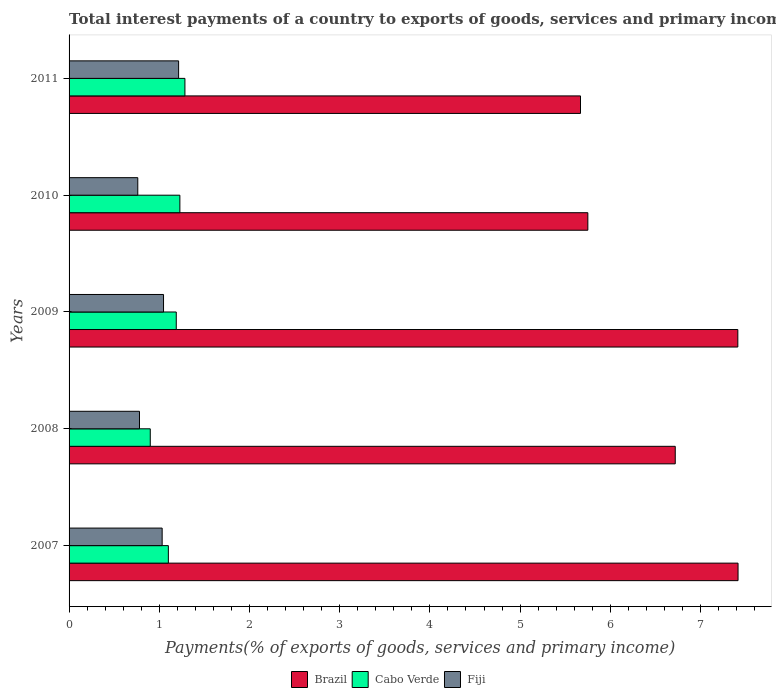How many groups of bars are there?
Your answer should be very brief. 5. Are the number of bars on each tick of the Y-axis equal?
Ensure brevity in your answer.  Yes. How many bars are there on the 3rd tick from the bottom?
Offer a very short reply. 3. What is the total interest payments in Fiji in 2008?
Offer a terse response. 0.78. Across all years, what is the maximum total interest payments in Fiji?
Provide a short and direct response. 1.21. Across all years, what is the minimum total interest payments in Cabo Verde?
Offer a terse response. 0.9. In which year was the total interest payments in Brazil maximum?
Keep it short and to the point. 2007. In which year was the total interest payments in Cabo Verde minimum?
Your answer should be compact. 2008. What is the total total interest payments in Brazil in the graph?
Ensure brevity in your answer.  32.97. What is the difference between the total interest payments in Cabo Verde in 2008 and that in 2011?
Your answer should be very brief. -0.38. What is the difference between the total interest payments in Fiji in 2010 and the total interest payments in Brazil in 2009?
Provide a succinct answer. -6.65. What is the average total interest payments in Fiji per year?
Your answer should be very brief. 0.97. In the year 2010, what is the difference between the total interest payments in Cabo Verde and total interest payments in Brazil?
Make the answer very short. -4.52. In how many years, is the total interest payments in Cabo Verde greater than 4 %?
Offer a terse response. 0. What is the ratio of the total interest payments in Cabo Verde in 2007 to that in 2009?
Offer a very short reply. 0.93. Is the total interest payments in Fiji in 2009 less than that in 2010?
Ensure brevity in your answer.  No. What is the difference between the highest and the second highest total interest payments in Cabo Verde?
Provide a short and direct response. 0.06. What is the difference between the highest and the lowest total interest payments in Brazil?
Make the answer very short. 1.75. In how many years, is the total interest payments in Brazil greater than the average total interest payments in Brazil taken over all years?
Offer a terse response. 3. What does the 3rd bar from the bottom in 2007 represents?
Provide a succinct answer. Fiji. Is it the case that in every year, the sum of the total interest payments in Fiji and total interest payments in Brazil is greater than the total interest payments in Cabo Verde?
Give a very brief answer. Yes. How many years are there in the graph?
Provide a short and direct response. 5. What is the difference between two consecutive major ticks on the X-axis?
Your answer should be very brief. 1. Where does the legend appear in the graph?
Your answer should be compact. Bottom center. How many legend labels are there?
Your answer should be compact. 3. How are the legend labels stacked?
Offer a terse response. Horizontal. What is the title of the graph?
Give a very brief answer. Total interest payments of a country to exports of goods, services and primary income. Does "New Caledonia" appear as one of the legend labels in the graph?
Your response must be concise. No. What is the label or title of the X-axis?
Offer a very short reply. Payments(% of exports of goods, services and primary income). What is the Payments(% of exports of goods, services and primary income) in Brazil in 2007?
Offer a terse response. 7.42. What is the Payments(% of exports of goods, services and primary income) of Cabo Verde in 2007?
Provide a succinct answer. 1.1. What is the Payments(% of exports of goods, services and primary income) in Fiji in 2007?
Make the answer very short. 1.03. What is the Payments(% of exports of goods, services and primary income) in Brazil in 2008?
Ensure brevity in your answer.  6.72. What is the Payments(% of exports of goods, services and primary income) in Cabo Verde in 2008?
Give a very brief answer. 0.9. What is the Payments(% of exports of goods, services and primary income) of Fiji in 2008?
Provide a short and direct response. 0.78. What is the Payments(% of exports of goods, services and primary income) in Brazil in 2009?
Offer a very short reply. 7.41. What is the Payments(% of exports of goods, services and primary income) of Cabo Verde in 2009?
Make the answer very short. 1.19. What is the Payments(% of exports of goods, services and primary income) in Fiji in 2009?
Give a very brief answer. 1.05. What is the Payments(% of exports of goods, services and primary income) in Brazil in 2010?
Make the answer very short. 5.75. What is the Payments(% of exports of goods, services and primary income) of Cabo Verde in 2010?
Provide a short and direct response. 1.23. What is the Payments(% of exports of goods, services and primary income) in Fiji in 2010?
Make the answer very short. 0.76. What is the Payments(% of exports of goods, services and primary income) in Brazil in 2011?
Your answer should be compact. 5.67. What is the Payments(% of exports of goods, services and primary income) of Cabo Verde in 2011?
Offer a very short reply. 1.28. What is the Payments(% of exports of goods, services and primary income) of Fiji in 2011?
Your response must be concise. 1.21. Across all years, what is the maximum Payments(% of exports of goods, services and primary income) of Brazil?
Ensure brevity in your answer.  7.42. Across all years, what is the maximum Payments(% of exports of goods, services and primary income) of Cabo Verde?
Offer a terse response. 1.28. Across all years, what is the maximum Payments(% of exports of goods, services and primary income) of Fiji?
Give a very brief answer. 1.21. Across all years, what is the minimum Payments(% of exports of goods, services and primary income) in Brazil?
Your response must be concise. 5.67. Across all years, what is the minimum Payments(% of exports of goods, services and primary income) of Cabo Verde?
Provide a short and direct response. 0.9. Across all years, what is the minimum Payments(% of exports of goods, services and primary income) in Fiji?
Offer a terse response. 0.76. What is the total Payments(% of exports of goods, services and primary income) of Brazil in the graph?
Give a very brief answer. 32.97. What is the total Payments(% of exports of goods, services and primary income) of Cabo Verde in the graph?
Ensure brevity in your answer.  5.7. What is the total Payments(% of exports of goods, services and primary income) of Fiji in the graph?
Offer a terse response. 4.84. What is the difference between the Payments(% of exports of goods, services and primary income) in Brazil in 2007 and that in 2008?
Make the answer very short. 0.7. What is the difference between the Payments(% of exports of goods, services and primary income) in Cabo Verde in 2007 and that in 2008?
Your answer should be compact. 0.2. What is the difference between the Payments(% of exports of goods, services and primary income) of Fiji in 2007 and that in 2008?
Ensure brevity in your answer.  0.25. What is the difference between the Payments(% of exports of goods, services and primary income) of Brazil in 2007 and that in 2009?
Provide a succinct answer. 0. What is the difference between the Payments(% of exports of goods, services and primary income) in Cabo Verde in 2007 and that in 2009?
Provide a short and direct response. -0.09. What is the difference between the Payments(% of exports of goods, services and primary income) in Fiji in 2007 and that in 2009?
Offer a very short reply. -0.02. What is the difference between the Payments(% of exports of goods, services and primary income) in Brazil in 2007 and that in 2010?
Offer a very short reply. 1.67. What is the difference between the Payments(% of exports of goods, services and primary income) of Cabo Verde in 2007 and that in 2010?
Your answer should be compact. -0.13. What is the difference between the Payments(% of exports of goods, services and primary income) in Fiji in 2007 and that in 2010?
Provide a succinct answer. 0.27. What is the difference between the Payments(% of exports of goods, services and primary income) in Brazil in 2007 and that in 2011?
Make the answer very short. 1.75. What is the difference between the Payments(% of exports of goods, services and primary income) in Cabo Verde in 2007 and that in 2011?
Provide a short and direct response. -0.18. What is the difference between the Payments(% of exports of goods, services and primary income) of Fiji in 2007 and that in 2011?
Make the answer very short. -0.18. What is the difference between the Payments(% of exports of goods, services and primary income) in Brazil in 2008 and that in 2009?
Ensure brevity in your answer.  -0.69. What is the difference between the Payments(% of exports of goods, services and primary income) in Cabo Verde in 2008 and that in 2009?
Ensure brevity in your answer.  -0.29. What is the difference between the Payments(% of exports of goods, services and primary income) in Fiji in 2008 and that in 2009?
Your answer should be compact. -0.27. What is the difference between the Payments(% of exports of goods, services and primary income) in Brazil in 2008 and that in 2010?
Offer a very short reply. 0.97. What is the difference between the Payments(% of exports of goods, services and primary income) in Cabo Verde in 2008 and that in 2010?
Keep it short and to the point. -0.33. What is the difference between the Payments(% of exports of goods, services and primary income) in Fiji in 2008 and that in 2010?
Provide a succinct answer. 0.02. What is the difference between the Payments(% of exports of goods, services and primary income) of Brazil in 2008 and that in 2011?
Your response must be concise. 1.05. What is the difference between the Payments(% of exports of goods, services and primary income) of Cabo Verde in 2008 and that in 2011?
Your response must be concise. -0.38. What is the difference between the Payments(% of exports of goods, services and primary income) in Fiji in 2008 and that in 2011?
Keep it short and to the point. -0.43. What is the difference between the Payments(% of exports of goods, services and primary income) of Brazil in 2009 and that in 2010?
Your answer should be compact. 1.66. What is the difference between the Payments(% of exports of goods, services and primary income) in Cabo Verde in 2009 and that in 2010?
Make the answer very short. -0.04. What is the difference between the Payments(% of exports of goods, services and primary income) of Fiji in 2009 and that in 2010?
Offer a very short reply. 0.29. What is the difference between the Payments(% of exports of goods, services and primary income) of Brazil in 2009 and that in 2011?
Make the answer very short. 1.74. What is the difference between the Payments(% of exports of goods, services and primary income) in Cabo Verde in 2009 and that in 2011?
Keep it short and to the point. -0.1. What is the difference between the Payments(% of exports of goods, services and primary income) in Fiji in 2009 and that in 2011?
Ensure brevity in your answer.  -0.17. What is the difference between the Payments(% of exports of goods, services and primary income) of Brazil in 2010 and that in 2011?
Provide a short and direct response. 0.08. What is the difference between the Payments(% of exports of goods, services and primary income) of Cabo Verde in 2010 and that in 2011?
Provide a succinct answer. -0.06. What is the difference between the Payments(% of exports of goods, services and primary income) of Fiji in 2010 and that in 2011?
Give a very brief answer. -0.45. What is the difference between the Payments(% of exports of goods, services and primary income) of Brazil in 2007 and the Payments(% of exports of goods, services and primary income) of Cabo Verde in 2008?
Provide a short and direct response. 6.52. What is the difference between the Payments(% of exports of goods, services and primary income) of Brazil in 2007 and the Payments(% of exports of goods, services and primary income) of Fiji in 2008?
Give a very brief answer. 6.64. What is the difference between the Payments(% of exports of goods, services and primary income) of Cabo Verde in 2007 and the Payments(% of exports of goods, services and primary income) of Fiji in 2008?
Offer a very short reply. 0.32. What is the difference between the Payments(% of exports of goods, services and primary income) in Brazil in 2007 and the Payments(% of exports of goods, services and primary income) in Cabo Verde in 2009?
Make the answer very short. 6.23. What is the difference between the Payments(% of exports of goods, services and primary income) in Brazil in 2007 and the Payments(% of exports of goods, services and primary income) in Fiji in 2009?
Your response must be concise. 6.37. What is the difference between the Payments(% of exports of goods, services and primary income) of Cabo Verde in 2007 and the Payments(% of exports of goods, services and primary income) of Fiji in 2009?
Make the answer very short. 0.05. What is the difference between the Payments(% of exports of goods, services and primary income) in Brazil in 2007 and the Payments(% of exports of goods, services and primary income) in Cabo Verde in 2010?
Keep it short and to the point. 6.19. What is the difference between the Payments(% of exports of goods, services and primary income) of Brazil in 2007 and the Payments(% of exports of goods, services and primary income) of Fiji in 2010?
Offer a terse response. 6.65. What is the difference between the Payments(% of exports of goods, services and primary income) of Cabo Verde in 2007 and the Payments(% of exports of goods, services and primary income) of Fiji in 2010?
Ensure brevity in your answer.  0.34. What is the difference between the Payments(% of exports of goods, services and primary income) in Brazil in 2007 and the Payments(% of exports of goods, services and primary income) in Cabo Verde in 2011?
Your response must be concise. 6.13. What is the difference between the Payments(% of exports of goods, services and primary income) in Brazil in 2007 and the Payments(% of exports of goods, services and primary income) in Fiji in 2011?
Ensure brevity in your answer.  6.2. What is the difference between the Payments(% of exports of goods, services and primary income) in Cabo Verde in 2007 and the Payments(% of exports of goods, services and primary income) in Fiji in 2011?
Ensure brevity in your answer.  -0.11. What is the difference between the Payments(% of exports of goods, services and primary income) of Brazil in 2008 and the Payments(% of exports of goods, services and primary income) of Cabo Verde in 2009?
Keep it short and to the point. 5.53. What is the difference between the Payments(% of exports of goods, services and primary income) in Brazil in 2008 and the Payments(% of exports of goods, services and primary income) in Fiji in 2009?
Make the answer very short. 5.67. What is the difference between the Payments(% of exports of goods, services and primary income) of Cabo Verde in 2008 and the Payments(% of exports of goods, services and primary income) of Fiji in 2009?
Your response must be concise. -0.15. What is the difference between the Payments(% of exports of goods, services and primary income) of Brazil in 2008 and the Payments(% of exports of goods, services and primary income) of Cabo Verde in 2010?
Make the answer very short. 5.49. What is the difference between the Payments(% of exports of goods, services and primary income) of Brazil in 2008 and the Payments(% of exports of goods, services and primary income) of Fiji in 2010?
Give a very brief answer. 5.96. What is the difference between the Payments(% of exports of goods, services and primary income) in Cabo Verde in 2008 and the Payments(% of exports of goods, services and primary income) in Fiji in 2010?
Offer a terse response. 0.14. What is the difference between the Payments(% of exports of goods, services and primary income) of Brazil in 2008 and the Payments(% of exports of goods, services and primary income) of Cabo Verde in 2011?
Give a very brief answer. 5.44. What is the difference between the Payments(% of exports of goods, services and primary income) of Brazil in 2008 and the Payments(% of exports of goods, services and primary income) of Fiji in 2011?
Provide a short and direct response. 5.51. What is the difference between the Payments(% of exports of goods, services and primary income) of Cabo Verde in 2008 and the Payments(% of exports of goods, services and primary income) of Fiji in 2011?
Keep it short and to the point. -0.31. What is the difference between the Payments(% of exports of goods, services and primary income) of Brazil in 2009 and the Payments(% of exports of goods, services and primary income) of Cabo Verde in 2010?
Offer a very short reply. 6.19. What is the difference between the Payments(% of exports of goods, services and primary income) of Brazil in 2009 and the Payments(% of exports of goods, services and primary income) of Fiji in 2010?
Make the answer very short. 6.65. What is the difference between the Payments(% of exports of goods, services and primary income) of Cabo Verde in 2009 and the Payments(% of exports of goods, services and primary income) of Fiji in 2010?
Ensure brevity in your answer.  0.43. What is the difference between the Payments(% of exports of goods, services and primary income) of Brazil in 2009 and the Payments(% of exports of goods, services and primary income) of Cabo Verde in 2011?
Make the answer very short. 6.13. What is the difference between the Payments(% of exports of goods, services and primary income) of Brazil in 2009 and the Payments(% of exports of goods, services and primary income) of Fiji in 2011?
Ensure brevity in your answer.  6.2. What is the difference between the Payments(% of exports of goods, services and primary income) of Cabo Verde in 2009 and the Payments(% of exports of goods, services and primary income) of Fiji in 2011?
Make the answer very short. -0.03. What is the difference between the Payments(% of exports of goods, services and primary income) in Brazil in 2010 and the Payments(% of exports of goods, services and primary income) in Cabo Verde in 2011?
Your answer should be very brief. 4.47. What is the difference between the Payments(% of exports of goods, services and primary income) of Brazil in 2010 and the Payments(% of exports of goods, services and primary income) of Fiji in 2011?
Provide a short and direct response. 4.54. What is the difference between the Payments(% of exports of goods, services and primary income) of Cabo Verde in 2010 and the Payments(% of exports of goods, services and primary income) of Fiji in 2011?
Your response must be concise. 0.01. What is the average Payments(% of exports of goods, services and primary income) in Brazil per year?
Your response must be concise. 6.59. What is the average Payments(% of exports of goods, services and primary income) in Cabo Verde per year?
Your answer should be very brief. 1.14. What is the average Payments(% of exports of goods, services and primary income) in Fiji per year?
Your answer should be very brief. 0.97. In the year 2007, what is the difference between the Payments(% of exports of goods, services and primary income) of Brazil and Payments(% of exports of goods, services and primary income) of Cabo Verde?
Provide a short and direct response. 6.32. In the year 2007, what is the difference between the Payments(% of exports of goods, services and primary income) of Brazil and Payments(% of exports of goods, services and primary income) of Fiji?
Offer a very short reply. 6.38. In the year 2007, what is the difference between the Payments(% of exports of goods, services and primary income) of Cabo Verde and Payments(% of exports of goods, services and primary income) of Fiji?
Keep it short and to the point. 0.07. In the year 2008, what is the difference between the Payments(% of exports of goods, services and primary income) in Brazil and Payments(% of exports of goods, services and primary income) in Cabo Verde?
Your answer should be very brief. 5.82. In the year 2008, what is the difference between the Payments(% of exports of goods, services and primary income) in Brazil and Payments(% of exports of goods, services and primary income) in Fiji?
Ensure brevity in your answer.  5.94. In the year 2008, what is the difference between the Payments(% of exports of goods, services and primary income) of Cabo Verde and Payments(% of exports of goods, services and primary income) of Fiji?
Ensure brevity in your answer.  0.12. In the year 2009, what is the difference between the Payments(% of exports of goods, services and primary income) of Brazil and Payments(% of exports of goods, services and primary income) of Cabo Verde?
Keep it short and to the point. 6.23. In the year 2009, what is the difference between the Payments(% of exports of goods, services and primary income) of Brazil and Payments(% of exports of goods, services and primary income) of Fiji?
Provide a short and direct response. 6.37. In the year 2009, what is the difference between the Payments(% of exports of goods, services and primary income) in Cabo Verde and Payments(% of exports of goods, services and primary income) in Fiji?
Your answer should be very brief. 0.14. In the year 2010, what is the difference between the Payments(% of exports of goods, services and primary income) of Brazil and Payments(% of exports of goods, services and primary income) of Cabo Verde?
Your answer should be very brief. 4.52. In the year 2010, what is the difference between the Payments(% of exports of goods, services and primary income) of Brazil and Payments(% of exports of goods, services and primary income) of Fiji?
Your answer should be very brief. 4.99. In the year 2010, what is the difference between the Payments(% of exports of goods, services and primary income) in Cabo Verde and Payments(% of exports of goods, services and primary income) in Fiji?
Your answer should be compact. 0.47. In the year 2011, what is the difference between the Payments(% of exports of goods, services and primary income) in Brazil and Payments(% of exports of goods, services and primary income) in Cabo Verde?
Your answer should be compact. 4.39. In the year 2011, what is the difference between the Payments(% of exports of goods, services and primary income) of Brazil and Payments(% of exports of goods, services and primary income) of Fiji?
Offer a very short reply. 4.46. In the year 2011, what is the difference between the Payments(% of exports of goods, services and primary income) of Cabo Verde and Payments(% of exports of goods, services and primary income) of Fiji?
Your answer should be very brief. 0.07. What is the ratio of the Payments(% of exports of goods, services and primary income) in Brazil in 2007 to that in 2008?
Ensure brevity in your answer.  1.1. What is the ratio of the Payments(% of exports of goods, services and primary income) in Cabo Verde in 2007 to that in 2008?
Offer a terse response. 1.22. What is the ratio of the Payments(% of exports of goods, services and primary income) in Fiji in 2007 to that in 2008?
Offer a terse response. 1.32. What is the ratio of the Payments(% of exports of goods, services and primary income) of Brazil in 2007 to that in 2009?
Your response must be concise. 1. What is the ratio of the Payments(% of exports of goods, services and primary income) of Cabo Verde in 2007 to that in 2009?
Keep it short and to the point. 0.93. What is the ratio of the Payments(% of exports of goods, services and primary income) in Fiji in 2007 to that in 2009?
Offer a very short reply. 0.99. What is the ratio of the Payments(% of exports of goods, services and primary income) of Brazil in 2007 to that in 2010?
Keep it short and to the point. 1.29. What is the ratio of the Payments(% of exports of goods, services and primary income) in Cabo Verde in 2007 to that in 2010?
Your answer should be very brief. 0.9. What is the ratio of the Payments(% of exports of goods, services and primary income) of Fiji in 2007 to that in 2010?
Keep it short and to the point. 1.35. What is the ratio of the Payments(% of exports of goods, services and primary income) in Brazil in 2007 to that in 2011?
Provide a succinct answer. 1.31. What is the ratio of the Payments(% of exports of goods, services and primary income) in Cabo Verde in 2007 to that in 2011?
Your response must be concise. 0.86. What is the ratio of the Payments(% of exports of goods, services and primary income) of Fiji in 2007 to that in 2011?
Provide a succinct answer. 0.85. What is the ratio of the Payments(% of exports of goods, services and primary income) of Brazil in 2008 to that in 2009?
Your response must be concise. 0.91. What is the ratio of the Payments(% of exports of goods, services and primary income) of Cabo Verde in 2008 to that in 2009?
Your response must be concise. 0.76. What is the ratio of the Payments(% of exports of goods, services and primary income) of Fiji in 2008 to that in 2009?
Ensure brevity in your answer.  0.75. What is the ratio of the Payments(% of exports of goods, services and primary income) in Brazil in 2008 to that in 2010?
Ensure brevity in your answer.  1.17. What is the ratio of the Payments(% of exports of goods, services and primary income) of Cabo Verde in 2008 to that in 2010?
Offer a terse response. 0.73. What is the ratio of the Payments(% of exports of goods, services and primary income) in Fiji in 2008 to that in 2010?
Ensure brevity in your answer.  1.02. What is the ratio of the Payments(% of exports of goods, services and primary income) in Brazil in 2008 to that in 2011?
Make the answer very short. 1.19. What is the ratio of the Payments(% of exports of goods, services and primary income) in Cabo Verde in 2008 to that in 2011?
Give a very brief answer. 0.7. What is the ratio of the Payments(% of exports of goods, services and primary income) in Fiji in 2008 to that in 2011?
Make the answer very short. 0.64. What is the ratio of the Payments(% of exports of goods, services and primary income) of Brazil in 2009 to that in 2010?
Keep it short and to the point. 1.29. What is the ratio of the Payments(% of exports of goods, services and primary income) of Cabo Verde in 2009 to that in 2010?
Provide a succinct answer. 0.97. What is the ratio of the Payments(% of exports of goods, services and primary income) in Fiji in 2009 to that in 2010?
Ensure brevity in your answer.  1.38. What is the ratio of the Payments(% of exports of goods, services and primary income) in Brazil in 2009 to that in 2011?
Make the answer very short. 1.31. What is the ratio of the Payments(% of exports of goods, services and primary income) in Cabo Verde in 2009 to that in 2011?
Ensure brevity in your answer.  0.93. What is the ratio of the Payments(% of exports of goods, services and primary income) in Fiji in 2009 to that in 2011?
Your answer should be very brief. 0.86. What is the ratio of the Payments(% of exports of goods, services and primary income) in Brazil in 2010 to that in 2011?
Your answer should be compact. 1.01. What is the ratio of the Payments(% of exports of goods, services and primary income) of Cabo Verde in 2010 to that in 2011?
Offer a terse response. 0.96. What is the ratio of the Payments(% of exports of goods, services and primary income) of Fiji in 2010 to that in 2011?
Offer a very short reply. 0.63. What is the difference between the highest and the second highest Payments(% of exports of goods, services and primary income) in Brazil?
Give a very brief answer. 0. What is the difference between the highest and the second highest Payments(% of exports of goods, services and primary income) of Cabo Verde?
Make the answer very short. 0.06. What is the difference between the highest and the second highest Payments(% of exports of goods, services and primary income) of Fiji?
Provide a short and direct response. 0.17. What is the difference between the highest and the lowest Payments(% of exports of goods, services and primary income) in Brazil?
Ensure brevity in your answer.  1.75. What is the difference between the highest and the lowest Payments(% of exports of goods, services and primary income) in Cabo Verde?
Your response must be concise. 0.38. What is the difference between the highest and the lowest Payments(% of exports of goods, services and primary income) in Fiji?
Your response must be concise. 0.45. 